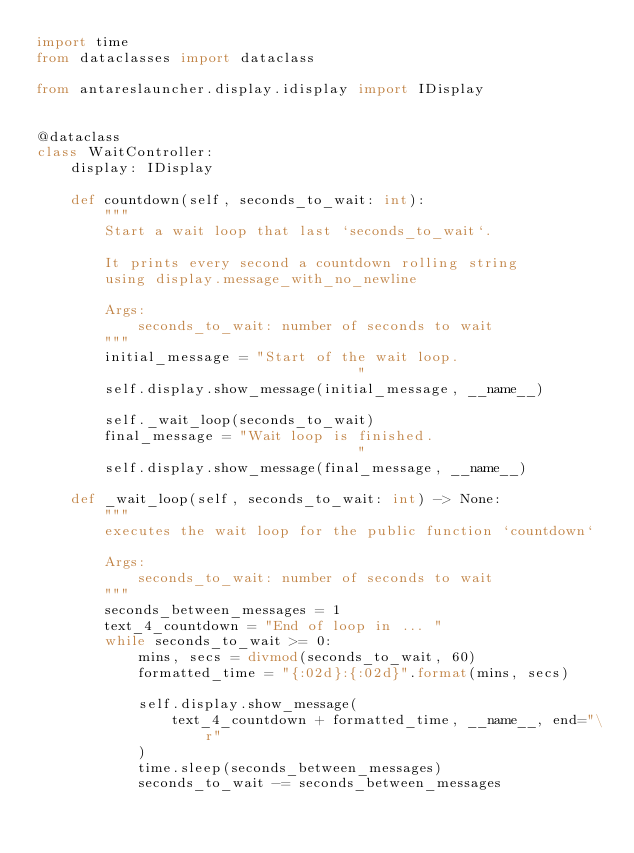<code> <loc_0><loc_0><loc_500><loc_500><_Python_>import time
from dataclasses import dataclass

from antareslauncher.display.idisplay import IDisplay


@dataclass
class WaitController:
    display: IDisplay

    def countdown(self, seconds_to_wait: int):
        """
        Start a wait loop that last `seconds_to_wait`.

        It prints every second a countdown rolling string
        using display.message_with_no_newline

        Args:
            seconds_to_wait: number of seconds to wait
        """
        initial_message = "Start of the wait loop.                           "
        self.display.show_message(initial_message, __name__)

        self._wait_loop(seconds_to_wait)
        final_message = "Wait loop is finished.                           "
        self.display.show_message(final_message, __name__)

    def _wait_loop(self, seconds_to_wait: int) -> None:
        """
        executes the wait loop for the public function `countdown`

        Args:
            seconds_to_wait: number of seconds to wait
        """
        seconds_between_messages = 1
        text_4_countdown = "End of loop in ... "
        while seconds_to_wait >= 0:
            mins, secs = divmod(seconds_to_wait, 60)
            formatted_time = "{:02d}:{:02d}".format(mins, secs)

            self.display.show_message(
                text_4_countdown + formatted_time, __name__, end="\r"
            )
            time.sleep(seconds_between_messages)
            seconds_to_wait -= seconds_between_messages
</code> 